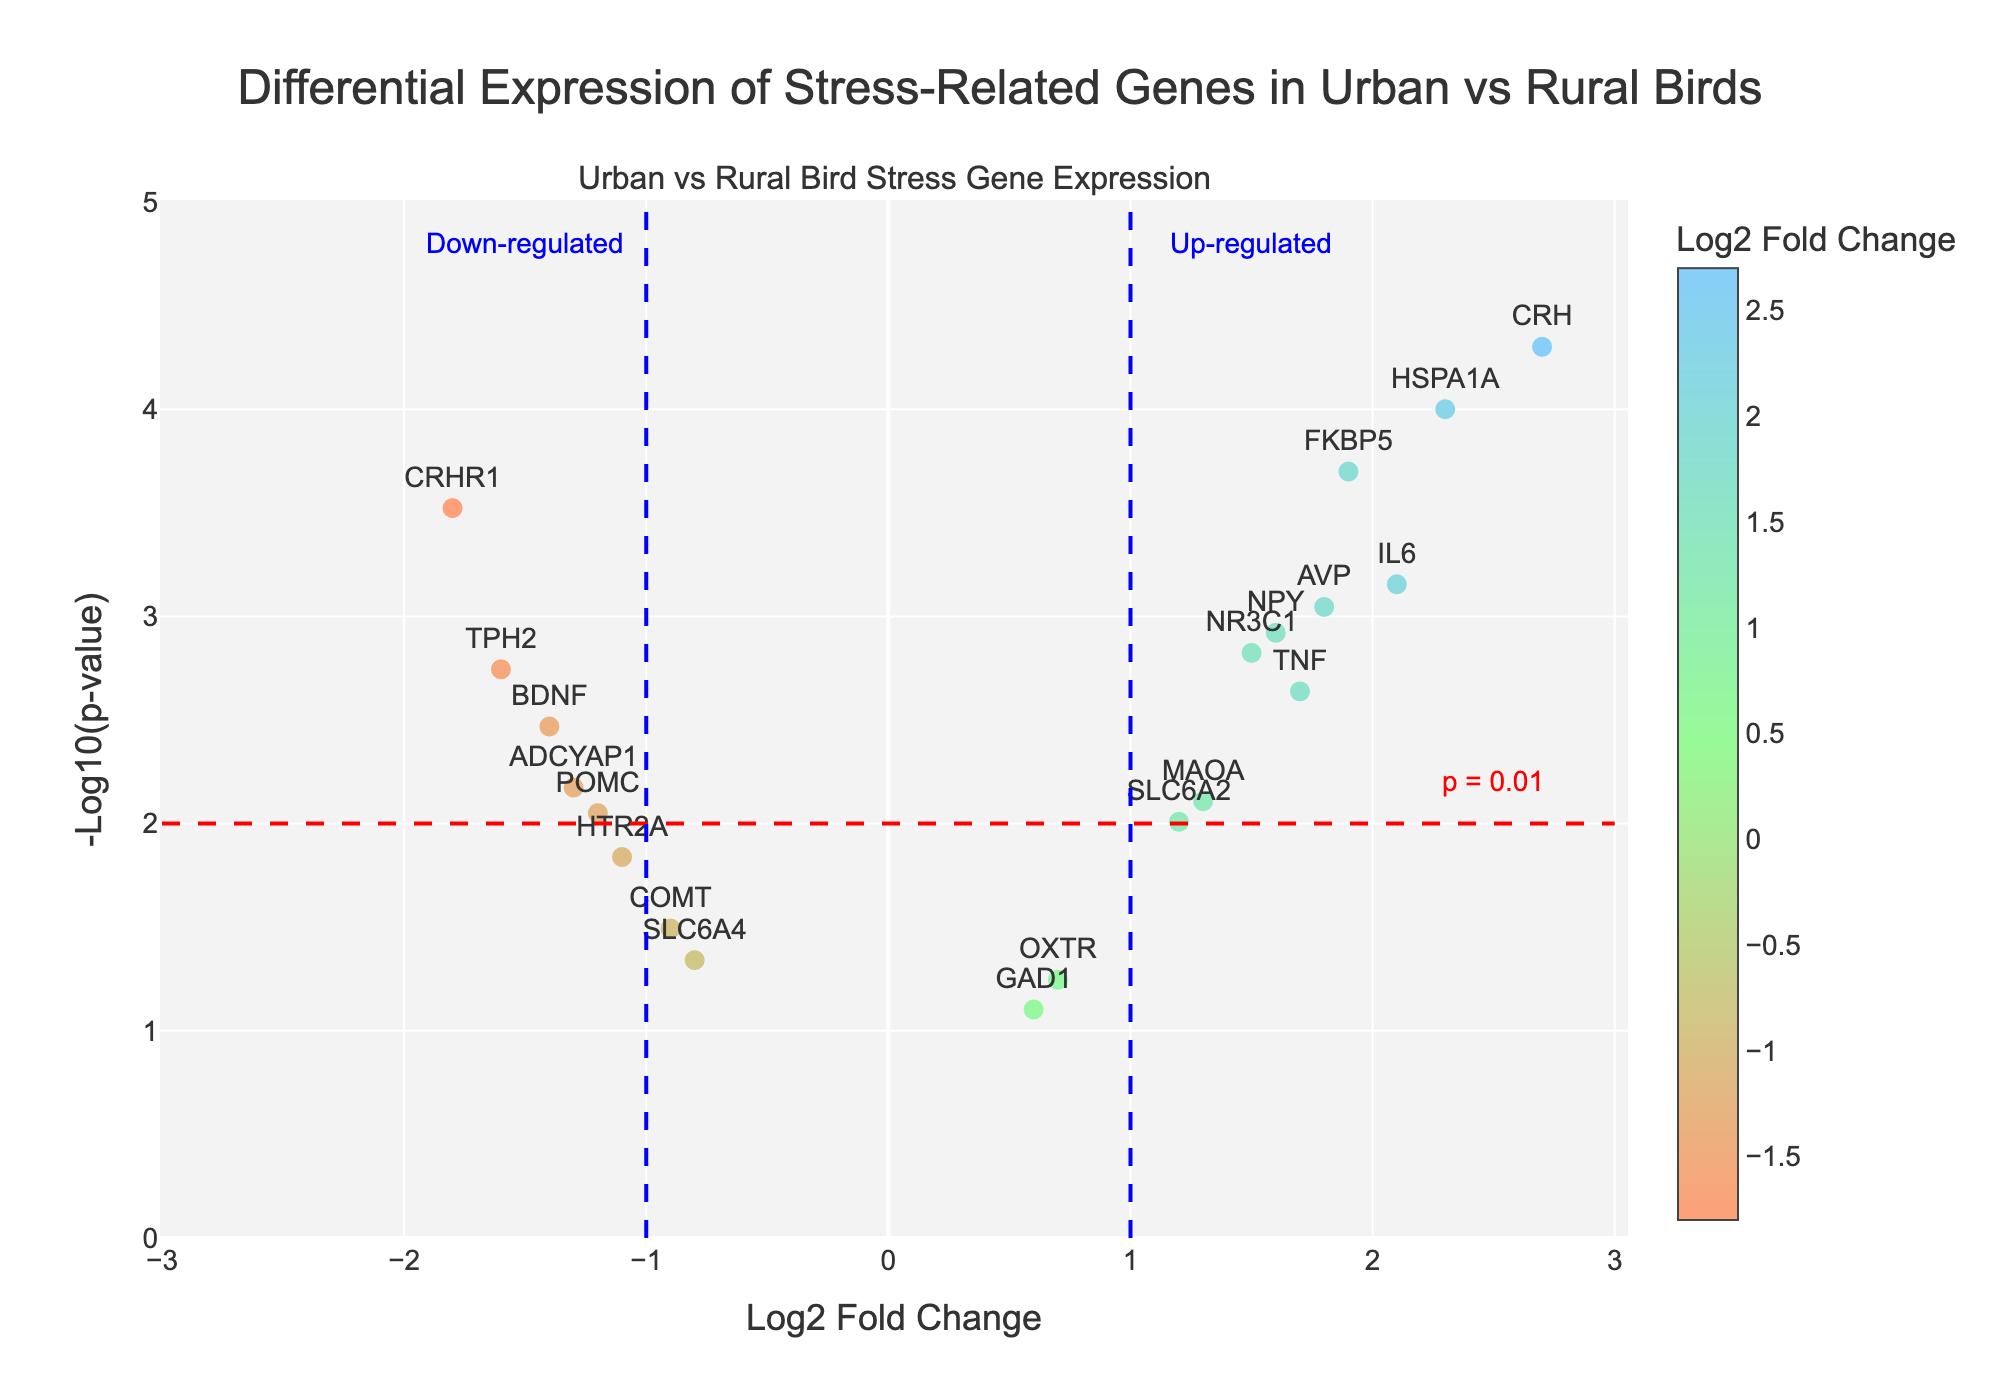How many genes are represented in the figure? Count the number of unique gene names displayed on the plot.
Answer: 20 What is the log2 fold change range of the genes? Identify the minimum and maximum values on the x-axis that indicate log2 fold change values.
Answer: -1.8 to 2.7 Which gene has the highest -log10(p-value)? Locate the gene positioned the highest on the y-axis.
Answer: CRH Which gene is the most down-regulated? Find the gene with the smallest (most negative) log2 fold change value.
Answer: CRHR1 Which genes have a log2 fold change greater than 1 and a p-value less than 0.001? Identify genes located to the right of log2 fold change = 1 and above the significance line (p = 0.001).
Answer: HSPA1A, CRH, FKBP5 What is the difference in log2 fold change between CRHR1 and TPH2? Subtract the log2 fold change value of TPH2 from the log2 fold change value of CRHR1.
Answer: -0.2 How many genes are up-regulated with a p-value less than 0.01? Count the number of genes to the right of log2 fold change = 1 and above the significance line (p = 0.01).
Answer: 6 Which gene has a log2 fold change closest to zero but is significant (p-value < 0.05)? Identify the gene nearest the y-axis within the significance range.
Answer: SLC6A4 What is the average log2 fold change of the up-regulated genes? Sum the log2 fold changes of all genes with positive values and divide by the number of up-regulated genes.
Answer: (2.3 + 1.5 + 2.7 + 1.9 + 1.6 + 2.1 + 1.7 + 1.3 + 1.2) / 9 = 1.71 Compare the significance of the genes POMC and HTR2A. Which one is more significant? Compare the -log10(p-value) of POMC and HTR2A and identify which is larger.
Answer: POMC 